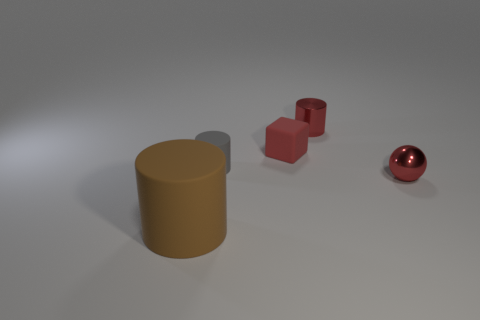The objects are resting on a surface; what does the surface look like? The surface in the image looks smooth and is rendered in a uniform grey color. The lighting of the scene suggests that the surface might have a slightly reflective quality, as indicated by the soft shadows and subtle reflections coming from the objects resting on it. 